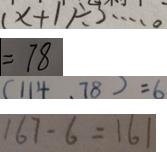Convert formula to latex. <formula><loc_0><loc_0><loc_500><loc_500>( x + 1 ) \div 3 \cdots 0 
 = 7 8 
 ( 1 1 4 , 7 8 ) = 6 
 1 6 7 - 6 = 1 6 1</formula> 